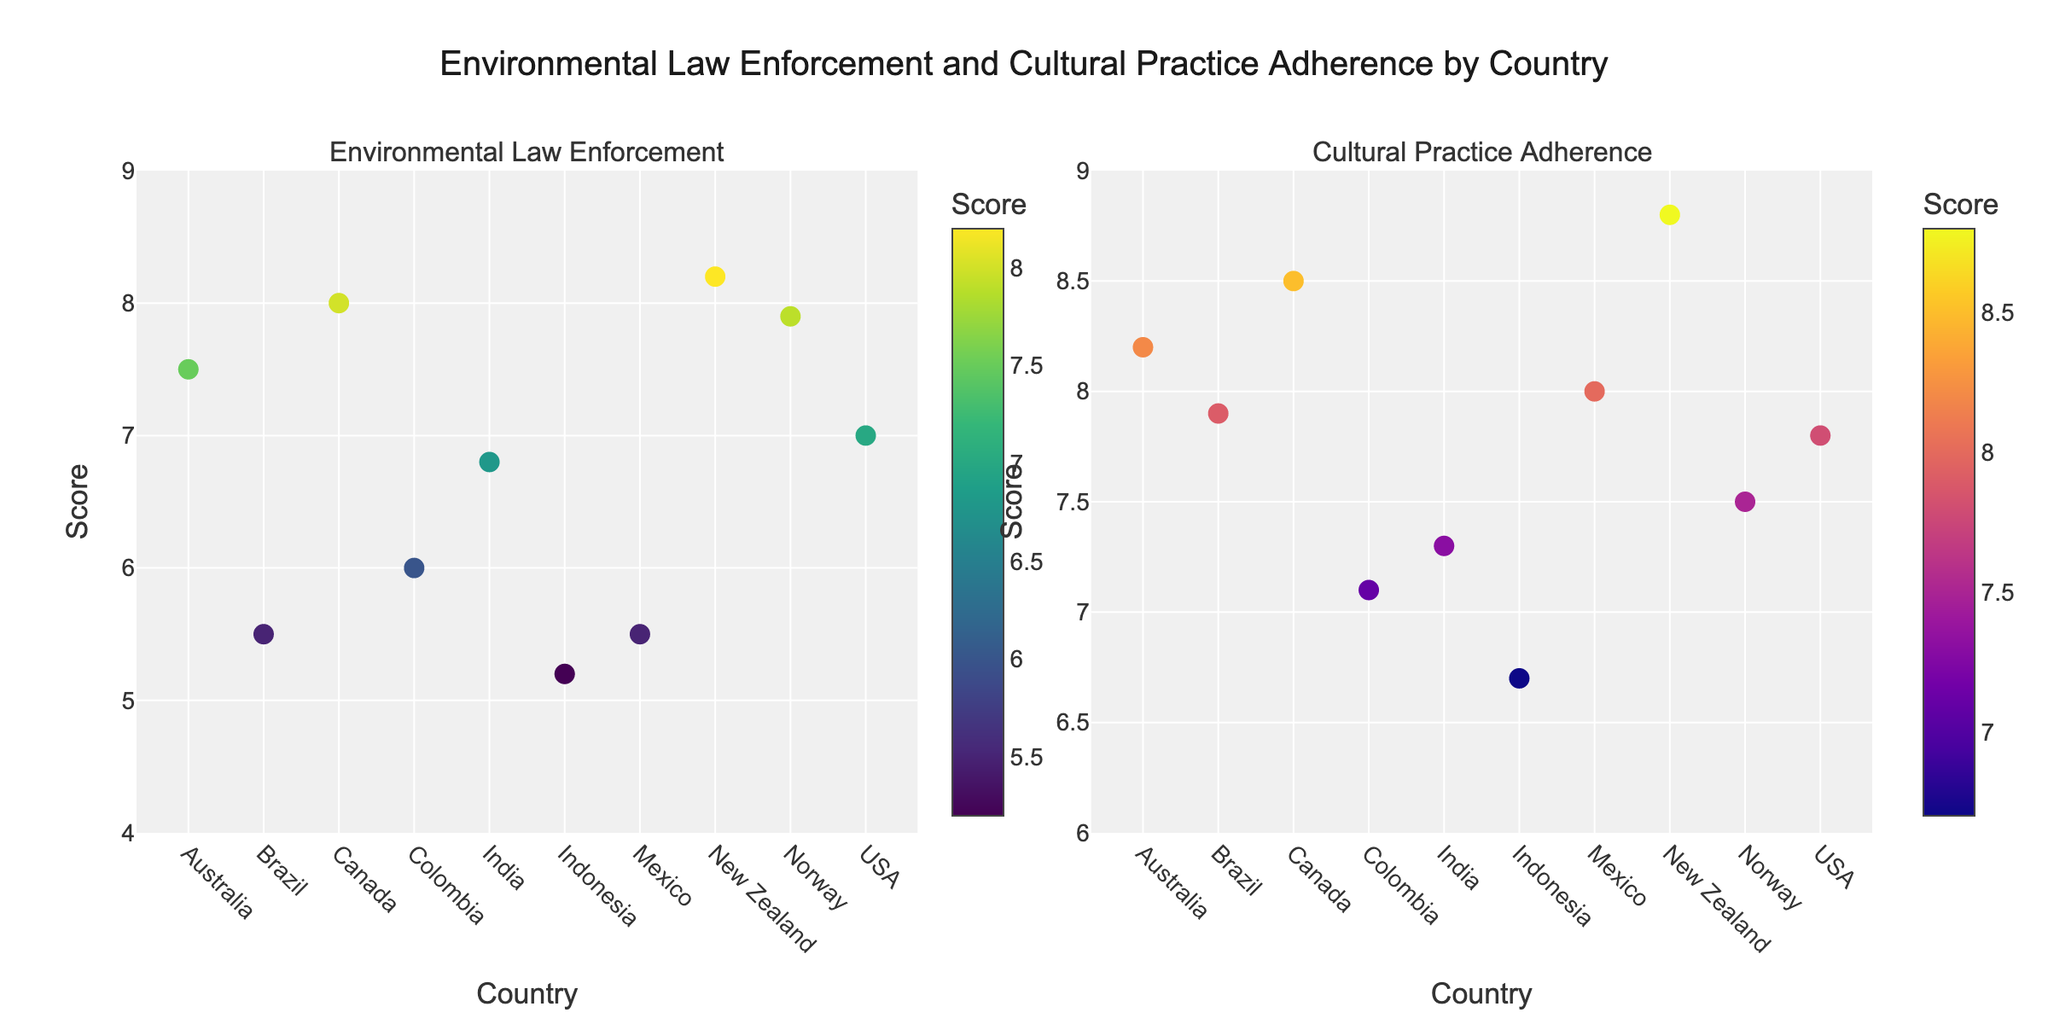What is the title of the figure? The title is displayed at the top of the figure. It reads "Environmental Law Enforcement and Cultural Practice Adherence by Country."
Answer: Environmental Law Enforcement and Cultural Practice Adherence by Country What country has the highest Environmental Law Enforcement Score? From the first subplot, New Zealand has the highest y-value for Environmental Law Enforcement Score, with a score of 8.2.
Answer: New Zealand Which indigenous group in the USA is represented in the figure? Hover over the markers in the USA data points in the figure. The text will show Navajo as the indigenous group.
Answer: Navajo How many countries have an Environmental Law Enforcement Score greater than 7.0? Observe the first subplot. Count the number of markers positioned above the 7.0 score line: Australia, Canada, New Zealand, and Norway. There are 4 countries.
Answer: 4 Which country has a Cultural Practice Adherence Score between 7.0 and 8.0? Look at the second subplot and identify markers within the range of 7.0 to 8.0 on the y-axis. Colombia with a score of 7.1 and Norway with a score of 7.5 fall within this range.
Answer: Colombia, Norway Compare the Environmental Law Enforcement Scores of Brazil and Mexico. Which is higher? Refer to the first subplot. Brazil and Mexico both have data points, Brazil has a score of 5.5, and Mexico also has a score of 5.5, making them equal.
Answer: Equal What is the average Cultural Practice Adherence Score for the indigenous groups in Canada and Australia? Locate and sum the scores from the second subplot for Canada (8.5) and Australia (8.2), then divide by 2. (8.5 + 8.2) / 2 = 8.35
Answer: 8.35 Which country has the lowest Cultural Practice Adherence Score? The second subplot shows Indonesia with the lowest y-value of 6.7 for Cultural Practice Adherence.
Answer: Indonesia Do any countries have an Environmental Law Enforcement Score and Cultural Practice Adherence Score both higher than 8.0? Examine both subplots for countries with scores above 8.0 in both categories. New Zealand with an 8.2 in Environmental Law Enforcement and 8.8 in Cultural Practice Adherence fits this criterion.
Answer: New Zealand 